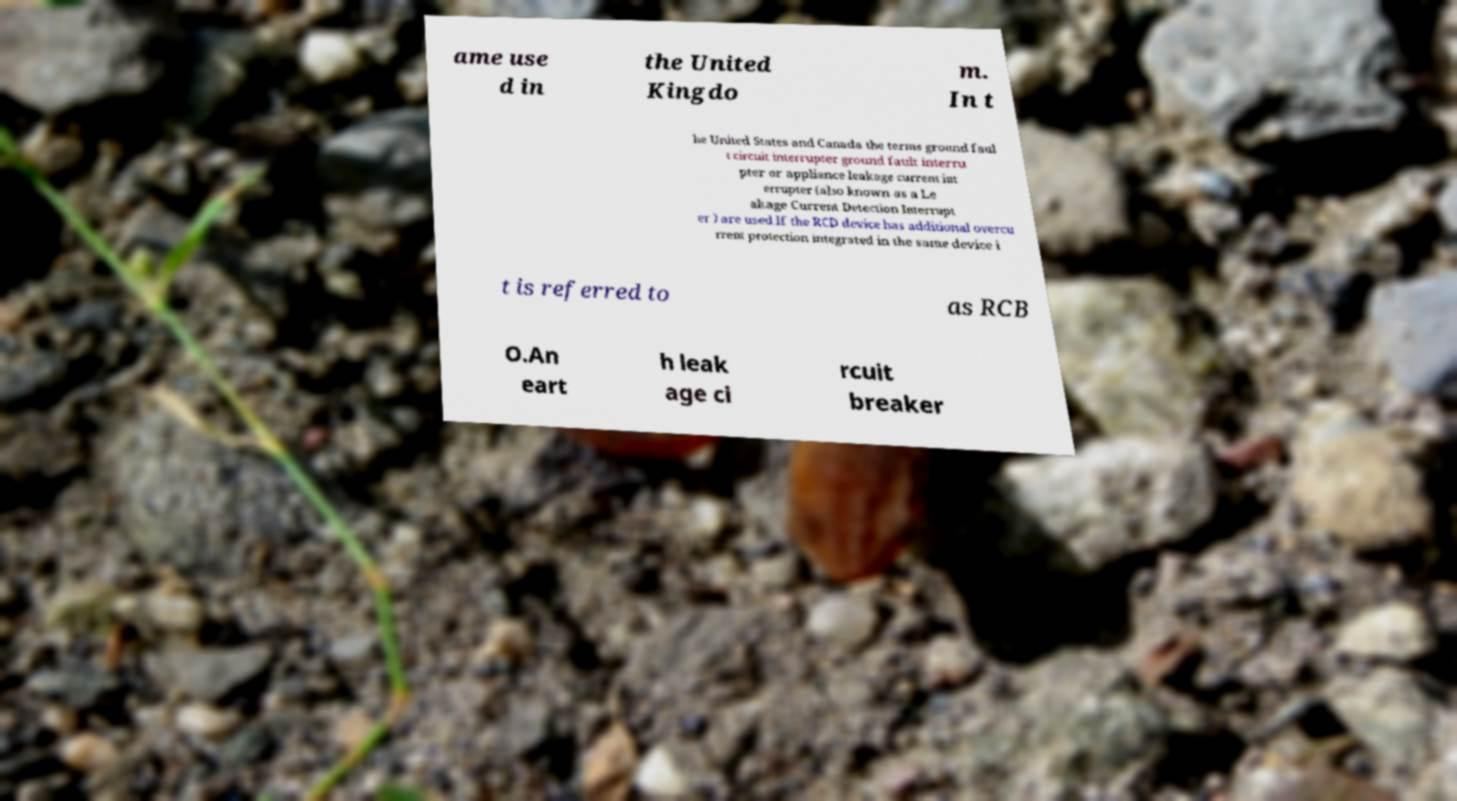Could you assist in decoding the text presented in this image and type it out clearly? ame use d in the United Kingdo m. In t he United States and Canada the terms ground faul t circuit interrupter ground fault interru pter or appliance leakage current int errupter (also known as a Le akage Current Detection Interrupt er ) are used.If the RCD device has additional overcu rrent protection integrated in the same device i t is referred to as RCB O.An eart h leak age ci rcuit breaker 